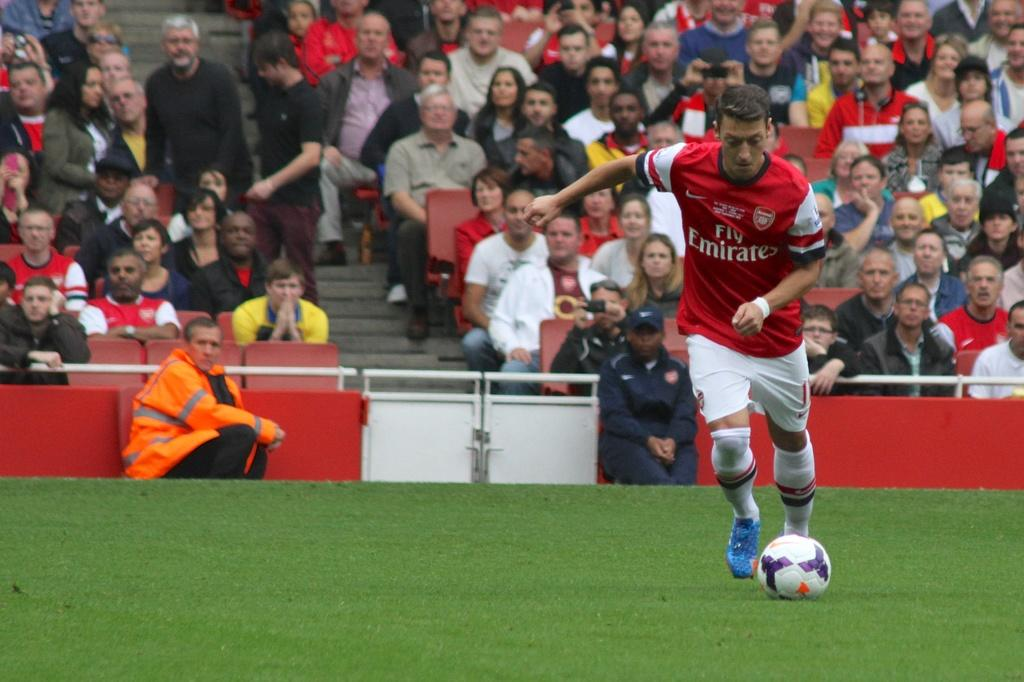<image>
Offer a succinct explanation of the picture presented. a man playing with a fly emirates shirt on 